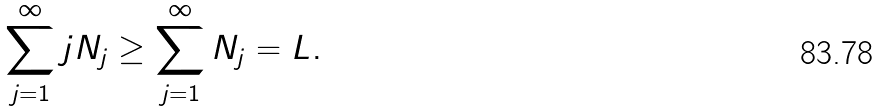<formula> <loc_0><loc_0><loc_500><loc_500>\sum _ { j = 1 } ^ { \infty } j N _ { j } \geq \sum _ { j = 1 } ^ { \infty } N _ { j } = L .</formula> 